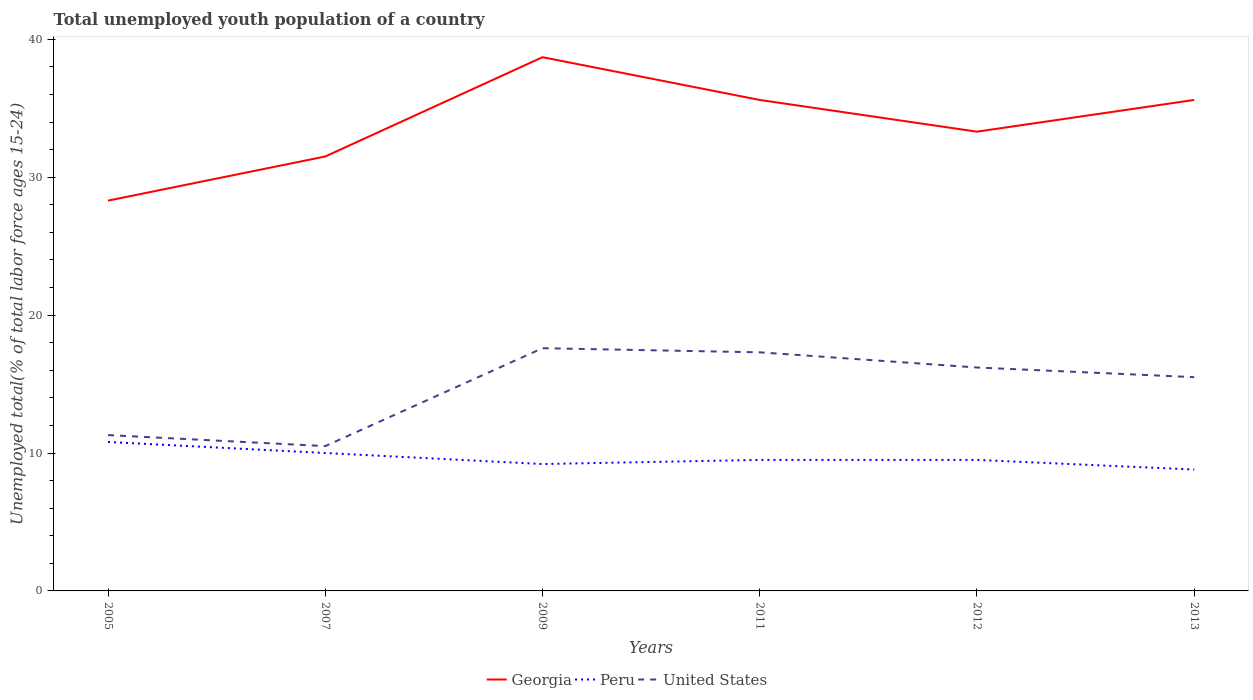Does the line corresponding to Georgia intersect with the line corresponding to United States?
Keep it short and to the point. No. Across all years, what is the maximum percentage of total unemployed youth population of a country in Georgia?
Offer a very short reply. 28.3. In which year was the percentage of total unemployed youth population of a country in United States maximum?
Make the answer very short. 2007. What is the total percentage of total unemployed youth population of a country in Georgia in the graph?
Your response must be concise. -7.3. What is the difference between the highest and the second highest percentage of total unemployed youth population of a country in Georgia?
Ensure brevity in your answer.  10.4. How many years are there in the graph?
Keep it short and to the point. 6. Does the graph contain any zero values?
Give a very brief answer. No. Where does the legend appear in the graph?
Your answer should be compact. Bottom center. How are the legend labels stacked?
Give a very brief answer. Horizontal. What is the title of the graph?
Give a very brief answer. Total unemployed youth population of a country. Does "Central African Republic" appear as one of the legend labels in the graph?
Offer a very short reply. No. What is the label or title of the X-axis?
Ensure brevity in your answer.  Years. What is the label or title of the Y-axis?
Keep it short and to the point. Unemployed total(% of total labor force ages 15-24). What is the Unemployed total(% of total labor force ages 15-24) of Georgia in 2005?
Your answer should be compact. 28.3. What is the Unemployed total(% of total labor force ages 15-24) of Peru in 2005?
Your response must be concise. 10.8. What is the Unemployed total(% of total labor force ages 15-24) in United States in 2005?
Give a very brief answer. 11.3. What is the Unemployed total(% of total labor force ages 15-24) of Georgia in 2007?
Your answer should be compact. 31.5. What is the Unemployed total(% of total labor force ages 15-24) in Georgia in 2009?
Offer a terse response. 38.7. What is the Unemployed total(% of total labor force ages 15-24) of Peru in 2009?
Give a very brief answer. 9.2. What is the Unemployed total(% of total labor force ages 15-24) in United States in 2009?
Your response must be concise. 17.6. What is the Unemployed total(% of total labor force ages 15-24) in Georgia in 2011?
Offer a very short reply. 35.6. What is the Unemployed total(% of total labor force ages 15-24) in United States in 2011?
Your answer should be very brief. 17.3. What is the Unemployed total(% of total labor force ages 15-24) in Georgia in 2012?
Offer a terse response. 33.3. What is the Unemployed total(% of total labor force ages 15-24) of Peru in 2012?
Give a very brief answer. 9.5. What is the Unemployed total(% of total labor force ages 15-24) in United States in 2012?
Your response must be concise. 16.2. What is the Unemployed total(% of total labor force ages 15-24) in Georgia in 2013?
Your response must be concise. 35.6. What is the Unemployed total(% of total labor force ages 15-24) of Peru in 2013?
Your answer should be compact. 8.8. What is the Unemployed total(% of total labor force ages 15-24) of United States in 2013?
Keep it short and to the point. 15.5. Across all years, what is the maximum Unemployed total(% of total labor force ages 15-24) in Georgia?
Your answer should be compact. 38.7. Across all years, what is the maximum Unemployed total(% of total labor force ages 15-24) in Peru?
Make the answer very short. 10.8. Across all years, what is the maximum Unemployed total(% of total labor force ages 15-24) in United States?
Provide a succinct answer. 17.6. Across all years, what is the minimum Unemployed total(% of total labor force ages 15-24) of Georgia?
Offer a very short reply. 28.3. Across all years, what is the minimum Unemployed total(% of total labor force ages 15-24) in Peru?
Keep it short and to the point. 8.8. Across all years, what is the minimum Unemployed total(% of total labor force ages 15-24) of United States?
Offer a very short reply. 10.5. What is the total Unemployed total(% of total labor force ages 15-24) of Georgia in the graph?
Ensure brevity in your answer.  203. What is the total Unemployed total(% of total labor force ages 15-24) of Peru in the graph?
Make the answer very short. 57.8. What is the total Unemployed total(% of total labor force ages 15-24) in United States in the graph?
Your response must be concise. 88.4. What is the difference between the Unemployed total(% of total labor force ages 15-24) in United States in 2005 and that in 2007?
Provide a succinct answer. 0.8. What is the difference between the Unemployed total(% of total labor force ages 15-24) of Georgia in 2005 and that in 2009?
Your answer should be very brief. -10.4. What is the difference between the Unemployed total(% of total labor force ages 15-24) of Peru in 2005 and that in 2009?
Your answer should be compact. 1.6. What is the difference between the Unemployed total(% of total labor force ages 15-24) of Georgia in 2005 and that in 2011?
Offer a very short reply. -7.3. What is the difference between the Unemployed total(% of total labor force ages 15-24) in Peru in 2005 and that in 2012?
Offer a terse response. 1.3. What is the difference between the Unemployed total(% of total labor force ages 15-24) in Peru in 2005 and that in 2013?
Your answer should be compact. 2. What is the difference between the Unemployed total(% of total labor force ages 15-24) in United States in 2005 and that in 2013?
Ensure brevity in your answer.  -4.2. What is the difference between the Unemployed total(% of total labor force ages 15-24) of Georgia in 2007 and that in 2009?
Keep it short and to the point. -7.2. What is the difference between the Unemployed total(% of total labor force ages 15-24) of Georgia in 2007 and that in 2011?
Offer a terse response. -4.1. What is the difference between the Unemployed total(% of total labor force ages 15-24) in Georgia in 2007 and that in 2012?
Your answer should be compact. -1.8. What is the difference between the Unemployed total(% of total labor force ages 15-24) in Peru in 2007 and that in 2012?
Make the answer very short. 0.5. What is the difference between the Unemployed total(% of total labor force ages 15-24) in United States in 2007 and that in 2012?
Keep it short and to the point. -5.7. What is the difference between the Unemployed total(% of total labor force ages 15-24) of Georgia in 2007 and that in 2013?
Give a very brief answer. -4.1. What is the difference between the Unemployed total(% of total labor force ages 15-24) in Peru in 2009 and that in 2011?
Keep it short and to the point. -0.3. What is the difference between the Unemployed total(% of total labor force ages 15-24) in Peru in 2009 and that in 2012?
Keep it short and to the point. -0.3. What is the difference between the Unemployed total(% of total labor force ages 15-24) in Georgia in 2009 and that in 2013?
Provide a succinct answer. 3.1. What is the difference between the Unemployed total(% of total labor force ages 15-24) in United States in 2009 and that in 2013?
Make the answer very short. 2.1. What is the difference between the Unemployed total(% of total labor force ages 15-24) in United States in 2011 and that in 2012?
Your answer should be very brief. 1.1. What is the difference between the Unemployed total(% of total labor force ages 15-24) of Georgia in 2011 and that in 2013?
Provide a short and direct response. 0. What is the difference between the Unemployed total(% of total labor force ages 15-24) of Peru in 2011 and that in 2013?
Keep it short and to the point. 0.7. What is the difference between the Unemployed total(% of total labor force ages 15-24) of United States in 2011 and that in 2013?
Make the answer very short. 1.8. What is the difference between the Unemployed total(% of total labor force ages 15-24) in Georgia in 2012 and that in 2013?
Keep it short and to the point. -2.3. What is the difference between the Unemployed total(% of total labor force ages 15-24) of Peru in 2012 and that in 2013?
Your answer should be compact. 0.7. What is the difference between the Unemployed total(% of total labor force ages 15-24) in Georgia in 2005 and the Unemployed total(% of total labor force ages 15-24) in Peru in 2007?
Your answer should be very brief. 18.3. What is the difference between the Unemployed total(% of total labor force ages 15-24) of Georgia in 2005 and the Unemployed total(% of total labor force ages 15-24) of United States in 2009?
Provide a succinct answer. 10.7. What is the difference between the Unemployed total(% of total labor force ages 15-24) of Georgia in 2005 and the Unemployed total(% of total labor force ages 15-24) of Peru in 2011?
Offer a terse response. 18.8. What is the difference between the Unemployed total(% of total labor force ages 15-24) of Georgia in 2005 and the Unemployed total(% of total labor force ages 15-24) of United States in 2011?
Offer a terse response. 11. What is the difference between the Unemployed total(% of total labor force ages 15-24) of Peru in 2005 and the Unemployed total(% of total labor force ages 15-24) of United States in 2011?
Keep it short and to the point. -6.5. What is the difference between the Unemployed total(% of total labor force ages 15-24) of Georgia in 2005 and the Unemployed total(% of total labor force ages 15-24) of Peru in 2012?
Ensure brevity in your answer.  18.8. What is the difference between the Unemployed total(% of total labor force ages 15-24) in Peru in 2005 and the Unemployed total(% of total labor force ages 15-24) in United States in 2012?
Offer a terse response. -5.4. What is the difference between the Unemployed total(% of total labor force ages 15-24) in Georgia in 2005 and the Unemployed total(% of total labor force ages 15-24) in United States in 2013?
Provide a succinct answer. 12.8. What is the difference between the Unemployed total(% of total labor force ages 15-24) in Georgia in 2007 and the Unemployed total(% of total labor force ages 15-24) in Peru in 2009?
Provide a succinct answer. 22.3. What is the difference between the Unemployed total(% of total labor force ages 15-24) of Georgia in 2007 and the Unemployed total(% of total labor force ages 15-24) of United States in 2009?
Provide a succinct answer. 13.9. What is the difference between the Unemployed total(% of total labor force ages 15-24) of Georgia in 2007 and the Unemployed total(% of total labor force ages 15-24) of Peru in 2012?
Provide a short and direct response. 22. What is the difference between the Unemployed total(% of total labor force ages 15-24) in Georgia in 2007 and the Unemployed total(% of total labor force ages 15-24) in Peru in 2013?
Your response must be concise. 22.7. What is the difference between the Unemployed total(% of total labor force ages 15-24) of Georgia in 2009 and the Unemployed total(% of total labor force ages 15-24) of Peru in 2011?
Provide a short and direct response. 29.2. What is the difference between the Unemployed total(% of total labor force ages 15-24) of Georgia in 2009 and the Unemployed total(% of total labor force ages 15-24) of United States in 2011?
Make the answer very short. 21.4. What is the difference between the Unemployed total(% of total labor force ages 15-24) in Peru in 2009 and the Unemployed total(% of total labor force ages 15-24) in United States in 2011?
Provide a short and direct response. -8.1. What is the difference between the Unemployed total(% of total labor force ages 15-24) in Georgia in 2009 and the Unemployed total(% of total labor force ages 15-24) in Peru in 2012?
Offer a very short reply. 29.2. What is the difference between the Unemployed total(% of total labor force ages 15-24) in Peru in 2009 and the Unemployed total(% of total labor force ages 15-24) in United States in 2012?
Your answer should be compact. -7. What is the difference between the Unemployed total(% of total labor force ages 15-24) in Georgia in 2009 and the Unemployed total(% of total labor force ages 15-24) in Peru in 2013?
Provide a succinct answer. 29.9. What is the difference between the Unemployed total(% of total labor force ages 15-24) of Georgia in 2009 and the Unemployed total(% of total labor force ages 15-24) of United States in 2013?
Your answer should be compact. 23.2. What is the difference between the Unemployed total(% of total labor force ages 15-24) in Georgia in 2011 and the Unemployed total(% of total labor force ages 15-24) in Peru in 2012?
Keep it short and to the point. 26.1. What is the difference between the Unemployed total(% of total labor force ages 15-24) in Georgia in 2011 and the Unemployed total(% of total labor force ages 15-24) in United States in 2012?
Your answer should be compact. 19.4. What is the difference between the Unemployed total(% of total labor force ages 15-24) of Georgia in 2011 and the Unemployed total(% of total labor force ages 15-24) of Peru in 2013?
Your answer should be very brief. 26.8. What is the difference between the Unemployed total(% of total labor force ages 15-24) in Georgia in 2011 and the Unemployed total(% of total labor force ages 15-24) in United States in 2013?
Provide a succinct answer. 20.1. What is the difference between the Unemployed total(% of total labor force ages 15-24) in Peru in 2011 and the Unemployed total(% of total labor force ages 15-24) in United States in 2013?
Offer a terse response. -6. What is the difference between the Unemployed total(% of total labor force ages 15-24) of Peru in 2012 and the Unemployed total(% of total labor force ages 15-24) of United States in 2013?
Keep it short and to the point. -6. What is the average Unemployed total(% of total labor force ages 15-24) in Georgia per year?
Offer a terse response. 33.83. What is the average Unemployed total(% of total labor force ages 15-24) of Peru per year?
Keep it short and to the point. 9.63. What is the average Unemployed total(% of total labor force ages 15-24) in United States per year?
Offer a very short reply. 14.73. In the year 2005, what is the difference between the Unemployed total(% of total labor force ages 15-24) of Peru and Unemployed total(% of total labor force ages 15-24) of United States?
Make the answer very short. -0.5. In the year 2007, what is the difference between the Unemployed total(% of total labor force ages 15-24) in Peru and Unemployed total(% of total labor force ages 15-24) in United States?
Your answer should be compact. -0.5. In the year 2009, what is the difference between the Unemployed total(% of total labor force ages 15-24) of Georgia and Unemployed total(% of total labor force ages 15-24) of Peru?
Provide a succinct answer. 29.5. In the year 2009, what is the difference between the Unemployed total(% of total labor force ages 15-24) of Georgia and Unemployed total(% of total labor force ages 15-24) of United States?
Ensure brevity in your answer.  21.1. In the year 2009, what is the difference between the Unemployed total(% of total labor force ages 15-24) in Peru and Unemployed total(% of total labor force ages 15-24) in United States?
Your answer should be very brief. -8.4. In the year 2011, what is the difference between the Unemployed total(% of total labor force ages 15-24) of Georgia and Unemployed total(% of total labor force ages 15-24) of Peru?
Ensure brevity in your answer.  26.1. In the year 2011, what is the difference between the Unemployed total(% of total labor force ages 15-24) in Georgia and Unemployed total(% of total labor force ages 15-24) in United States?
Offer a terse response. 18.3. In the year 2011, what is the difference between the Unemployed total(% of total labor force ages 15-24) of Peru and Unemployed total(% of total labor force ages 15-24) of United States?
Provide a succinct answer. -7.8. In the year 2012, what is the difference between the Unemployed total(% of total labor force ages 15-24) in Georgia and Unemployed total(% of total labor force ages 15-24) in Peru?
Provide a succinct answer. 23.8. In the year 2012, what is the difference between the Unemployed total(% of total labor force ages 15-24) in Georgia and Unemployed total(% of total labor force ages 15-24) in United States?
Ensure brevity in your answer.  17.1. In the year 2013, what is the difference between the Unemployed total(% of total labor force ages 15-24) in Georgia and Unemployed total(% of total labor force ages 15-24) in Peru?
Your answer should be very brief. 26.8. In the year 2013, what is the difference between the Unemployed total(% of total labor force ages 15-24) in Georgia and Unemployed total(% of total labor force ages 15-24) in United States?
Your answer should be very brief. 20.1. In the year 2013, what is the difference between the Unemployed total(% of total labor force ages 15-24) in Peru and Unemployed total(% of total labor force ages 15-24) in United States?
Provide a short and direct response. -6.7. What is the ratio of the Unemployed total(% of total labor force ages 15-24) in Georgia in 2005 to that in 2007?
Provide a short and direct response. 0.9. What is the ratio of the Unemployed total(% of total labor force ages 15-24) in Peru in 2005 to that in 2007?
Provide a succinct answer. 1.08. What is the ratio of the Unemployed total(% of total labor force ages 15-24) in United States in 2005 to that in 2007?
Ensure brevity in your answer.  1.08. What is the ratio of the Unemployed total(% of total labor force ages 15-24) of Georgia in 2005 to that in 2009?
Make the answer very short. 0.73. What is the ratio of the Unemployed total(% of total labor force ages 15-24) of Peru in 2005 to that in 2009?
Offer a very short reply. 1.17. What is the ratio of the Unemployed total(% of total labor force ages 15-24) in United States in 2005 to that in 2009?
Offer a very short reply. 0.64. What is the ratio of the Unemployed total(% of total labor force ages 15-24) in Georgia in 2005 to that in 2011?
Give a very brief answer. 0.79. What is the ratio of the Unemployed total(% of total labor force ages 15-24) in Peru in 2005 to that in 2011?
Keep it short and to the point. 1.14. What is the ratio of the Unemployed total(% of total labor force ages 15-24) of United States in 2005 to that in 2011?
Make the answer very short. 0.65. What is the ratio of the Unemployed total(% of total labor force ages 15-24) in Georgia in 2005 to that in 2012?
Provide a short and direct response. 0.85. What is the ratio of the Unemployed total(% of total labor force ages 15-24) of Peru in 2005 to that in 2012?
Provide a short and direct response. 1.14. What is the ratio of the Unemployed total(% of total labor force ages 15-24) of United States in 2005 to that in 2012?
Offer a very short reply. 0.7. What is the ratio of the Unemployed total(% of total labor force ages 15-24) in Georgia in 2005 to that in 2013?
Offer a terse response. 0.79. What is the ratio of the Unemployed total(% of total labor force ages 15-24) of Peru in 2005 to that in 2013?
Provide a succinct answer. 1.23. What is the ratio of the Unemployed total(% of total labor force ages 15-24) in United States in 2005 to that in 2013?
Give a very brief answer. 0.73. What is the ratio of the Unemployed total(% of total labor force ages 15-24) in Georgia in 2007 to that in 2009?
Your answer should be very brief. 0.81. What is the ratio of the Unemployed total(% of total labor force ages 15-24) of Peru in 2007 to that in 2009?
Provide a short and direct response. 1.09. What is the ratio of the Unemployed total(% of total labor force ages 15-24) of United States in 2007 to that in 2009?
Your response must be concise. 0.6. What is the ratio of the Unemployed total(% of total labor force ages 15-24) in Georgia in 2007 to that in 2011?
Your answer should be very brief. 0.88. What is the ratio of the Unemployed total(% of total labor force ages 15-24) in Peru in 2007 to that in 2011?
Give a very brief answer. 1.05. What is the ratio of the Unemployed total(% of total labor force ages 15-24) in United States in 2007 to that in 2011?
Give a very brief answer. 0.61. What is the ratio of the Unemployed total(% of total labor force ages 15-24) in Georgia in 2007 to that in 2012?
Offer a terse response. 0.95. What is the ratio of the Unemployed total(% of total labor force ages 15-24) in Peru in 2007 to that in 2012?
Your response must be concise. 1.05. What is the ratio of the Unemployed total(% of total labor force ages 15-24) in United States in 2007 to that in 2012?
Your answer should be very brief. 0.65. What is the ratio of the Unemployed total(% of total labor force ages 15-24) in Georgia in 2007 to that in 2013?
Your answer should be compact. 0.88. What is the ratio of the Unemployed total(% of total labor force ages 15-24) in Peru in 2007 to that in 2013?
Provide a short and direct response. 1.14. What is the ratio of the Unemployed total(% of total labor force ages 15-24) of United States in 2007 to that in 2013?
Ensure brevity in your answer.  0.68. What is the ratio of the Unemployed total(% of total labor force ages 15-24) of Georgia in 2009 to that in 2011?
Provide a short and direct response. 1.09. What is the ratio of the Unemployed total(% of total labor force ages 15-24) of Peru in 2009 to that in 2011?
Your response must be concise. 0.97. What is the ratio of the Unemployed total(% of total labor force ages 15-24) in United States in 2009 to that in 2011?
Offer a very short reply. 1.02. What is the ratio of the Unemployed total(% of total labor force ages 15-24) in Georgia in 2009 to that in 2012?
Keep it short and to the point. 1.16. What is the ratio of the Unemployed total(% of total labor force ages 15-24) of Peru in 2009 to that in 2012?
Keep it short and to the point. 0.97. What is the ratio of the Unemployed total(% of total labor force ages 15-24) in United States in 2009 to that in 2012?
Keep it short and to the point. 1.09. What is the ratio of the Unemployed total(% of total labor force ages 15-24) of Georgia in 2009 to that in 2013?
Your answer should be compact. 1.09. What is the ratio of the Unemployed total(% of total labor force ages 15-24) of Peru in 2009 to that in 2013?
Keep it short and to the point. 1.05. What is the ratio of the Unemployed total(% of total labor force ages 15-24) in United States in 2009 to that in 2013?
Offer a terse response. 1.14. What is the ratio of the Unemployed total(% of total labor force ages 15-24) in Georgia in 2011 to that in 2012?
Keep it short and to the point. 1.07. What is the ratio of the Unemployed total(% of total labor force ages 15-24) in United States in 2011 to that in 2012?
Provide a succinct answer. 1.07. What is the ratio of the Unemployed total(% of total labor force ages 15-24) in Georgia in 2011 to that in 2013?
Offer a very short reply. 1. What is the ratio of the Unemployed total(% of total labor force ages 15-24) in Peru in 2011 to that in 2013?
Give a very brief answer. 1.08. What is the ratio of the Unemployed total(% of total labor force ages 15-24) in United States in 2011 to that in 2013?
Ensure brevity in your answer.  1.12. What is the ratio of the Unemployed total(% of total labor force ages 15-24) in Georgia in 2012 to that in 2013?
Keep it short and to the point. 0.94. What is the ratio of the Unemployed total(% of total labor force ages 15-24) of Peru in 2012 to that in 2013?
Your response must be concise. 1.08. What is the ratio of the Unemployed total(% of total labor force ages 15-24) in United States in 2012 to that in 2013?
Your response must be concise. 1.05. What is the difference between the highest and the second highest Unemployed total(% of total labor force ages 15-24) in Georgia?
Keep it short and to the point. 3.1. What is the difference between the highest and the second highest Unemployed total(% of total labor force ages 15-24) in Peru?
Ensure brevity in your answer.  0.8. What is the difference between the highest and the second highest Unemployed total(% of total labor force ages 15-24) in United States?
Give a very brief answer. 0.3. What is the difference between the highest and the lowest Unemployed total(% of total labor force ages 15-24) of United States?
Your answer should be compact. 7.1. 